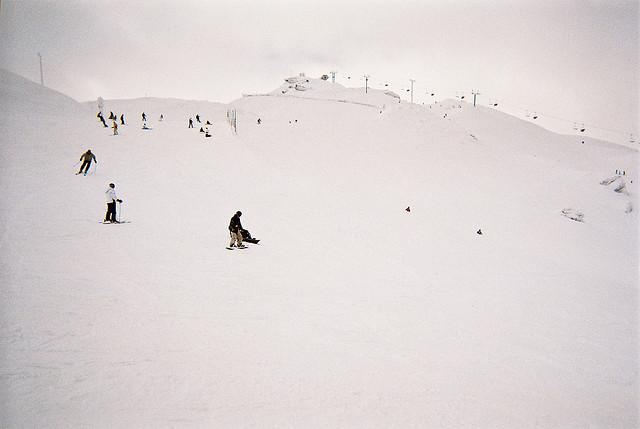What kind of sport are the people pictured above playing?

Choices:
A) ice skating
B) broomball
C) sledding
D) skiing skiing 